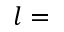Convert formula to latex. <formula><loc_0><loc_0><loc_500><loc_500>l =</formula> 